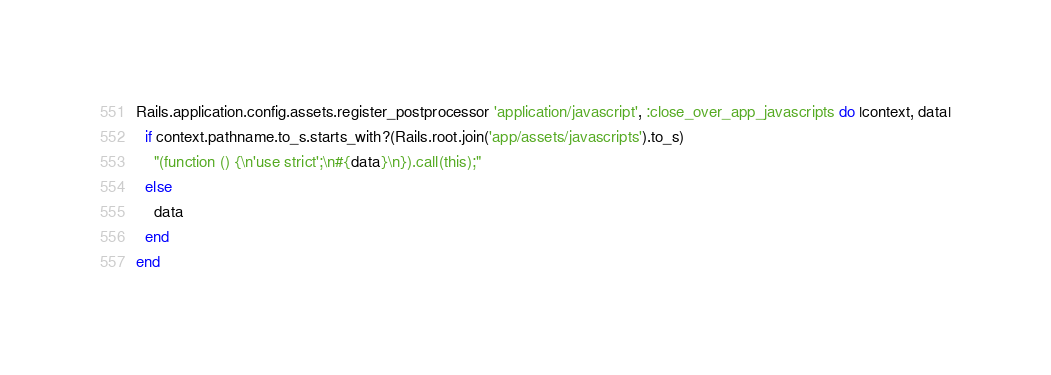Convert code to text. <code><loc_0><loc_0><loc_500><loc_500><_Ruby_>Rails.application.config.assets.register_postprocessor 'application/javascript', :close_over_app_javascripts do |context, data|
  if context.pathname.to_s.starts_with?(Rails.root.join('app/assets/javascripts').to_s)
    "(function () {\n'use strict';\n#{data}\n}).call(this);"
  else
    data
  end
end
</code> 